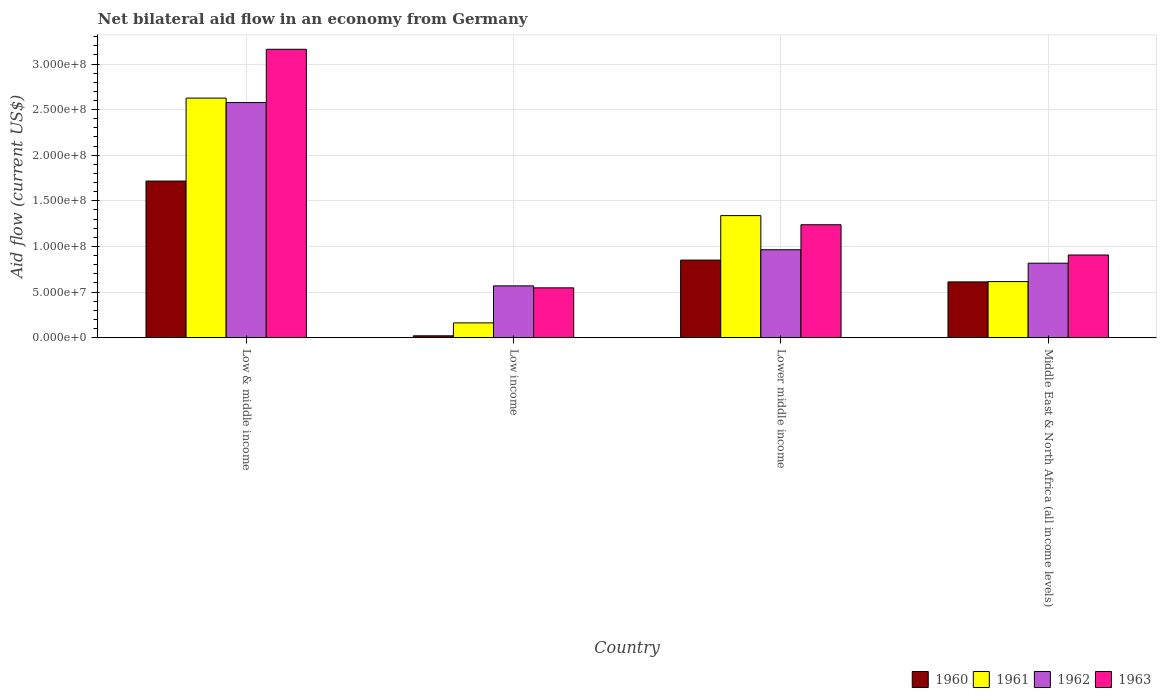How many groups of bars are there?
Provide a succinct answer. 4. Are the number of bars per tick equal to the number of legend labels?
Your answer should be very brief. Yes. How many bars are there on the 3rd tick from the left?
Make the answer very short. 4. How many bars are there on the 1st tick from the right?
Provide a short and direct response. 4. What is the net bilateral aid flow in 1963 in Low & middle income?
Provide a succinct answer. 3.16e+08. Across all countries, what is the maximum net bilateral aid flow in 1961?
Offer a very short reply. 2.63e+08. Across all countries, what is the minimum net bilateral aid flow in 1962?
Your response must be concise. 5.68e+07. In which country was the net bilateral aid flow in 1961 maximum?
Your answer should be very brief. Low & middle income. What is the total net bilateral aid flow in 1962 in the graph?
Your response must be concise. 4.93e+08. What is the difference between the net bilateral aid flow in 1962 in Low & middle income and that in Middle East & North Africa (all income levels)?
Offer a very short reply. 1.76e+08. What is the difference between the net bilateral aid flow in 1962 in Low income and the net bilateral aid flow in 1960 in Lower middle income?
Your answer should be compact. -2.82e+07. What is the average net bilateral aid flow in 1960 per country?
Your response must be concise. 8.00e+07. What is the difference between the net bilateral aid flow of/in 1961 and net bilateral aid flow of/in 1960 in Low income?
Make the answer very short. 1.42e+07. What is the ratio of the net bilateral aid flow in 1961 in Lower middle income to that in Middle East & North Africa (all income levels)?
Your answer should be very brief. 2.18. What is the difference between the highest and the second highest net bilateral aid flow in 1963?
Provide a short and direct response. 2.26e+08. What is the difference between the highest and the lowest net bilateral aid flow in 1961?
Give a very brief answer. 2.46e+08. In how many countries, is the net bilateral aid flow in 1962 greater than the average net bilateral aid flow in 1962 taken over all countries?
Offer a terse response. 1. Is the sum of the net bilateral aid flow in 1963 in Low & middle income and Low income greater than the maximum net bilateral aid flow in 1960 across all countries?
Your response must be concise. Yes. Is it the case that in every country, the sum of the net bilateral aid flow in 1961 and net bilateral aid flow in 1960 is greater than the sum of net bilateral aid flow in 1963 and net bilateral aid flow in 1962?
Offer a terse response. No. What does the 3rd bar from the left in Low & middle income represents?
Offer a terse response. 1962. Are all the bars in the graph horizontal?
Provide a short and direct response. No. What is the difference between two consecutive major ticks on the Y-axis?
Your answer should be compact. 5.00e+07. Are the values on the major ticks of Y-axis written in scientific E-notation?
Offer a very short reply. Yes. Does the graph contain any zero values?
Provide a succinct answer. No. Does the graph contain grids?
Your answer should be compact. Yes. How are the legend labels stacked?
Provide a succinct answer. Horizontal. What is the title of the graph?
Your answer should be compact. Net bilateral aid flow in an economy from Germany. Does "1972" appear as one of the legend labels in the graph?
Make the answer very short. No. What is the Aid flow (current US$) of 1960 in Low & middle income?
Provide a succinct answer. 1.72e+08. What is the Aid flow (current US$) in 1961 in Low & middle income?
Give a very brief answer. 2.63e+08. What is the Aid flow (current US$) in 1962 in Low & middle income?
Offer a very short reply. 2.58e+08. What is the Aid flow (current US$) of 1963 in Low & middle income?
Make the answer very short. 3.16e+08. What is the Aid flow (current US$) of 1960 in Low income?
Your answer should be very brief. 2.02e+06. What is the Aid flow (current US$) of 1961 in Low income?
Offer a terse response. 1.62e+07. What is the Aid flow (current US$) in 1962 in Low income?
Provide a succinct answer. 5.68e+07. What is the Aid flow (current US$) of 1963 in Low income?
Your response must be concise. 5.46e+07. What is the Aid flow (current US$) in 1960 in Lower middle income?
Provide a succinct answer. 8.50e+07. What is the Aid flow (current US$) of 1961 in Lower middle income?
Keep it short and to the point. 1.34e+08. What is the Aid flow (current US$) in 1962 in Lower middle income?
Your response must be concise. 9.64e+07. What is the Aid flow (current US$) of 1963 in Lower middle income?
Make the answer very short. 1.24e+08. What is the Aid flow (current US$) of 1960 in Middle East & North Africa (all income levels)?
Your answer should be very brief. 6.11e+07. What is the Aid flow (current US$) of 1961 in Middle East & North Africa (all income levels)?
Your response must be concise. 6.15e+07. What is the Aid flow (current US$) of 1962 in Middle East & North Africa (all income levels)?
Keep it short and to the point. 8.16e+07. What is the Aid flow (current US$) in 1963 in Middle East & North Africa (all income levels)?
Offer a very short reply. 9.06e+07. Across all countries, what is the maximum Aid flow (current US$) of 1960?
Your answer should be compact. 1.72e+08. Across all countries, what is the maximum Aid flow (current US$) in 1961?
Keep it short and to the point. 2.63e+08. Across all countries, what is the maximum Aid flow (current US$) of 1962?
Give a very brief answer. 2.58e+08. Across all countries, what is the maximum Aid flow (current US$) of 1963?
Keep it short and to the point. 3.16e+08. Across all countries, what is the minimum Aid flow (current US$) of 1960?
Ensure brevity in your answer.  2.02e+06. Across all countries, what is the minimum Aid flow (current US$) of 1961?
Provide a short and direct response. 1.62e+07. Across all countries, what is the minimum Aid flow (current US$) of 1962?
Provide a short and direct response. 5.68e+07. Across all countries, what is the minimum Aid flow (current US$) in 1963?
Keep it short and to the point. 5.46e+07. What is the total Aid flow (current US$) in 1960 in the graph?
Keep it short and to the point. 3.20e+08. What is the total Aid flow (current US$) in 1961 in the graph?
Your answer should be very brief. 4.74e+08. What is the total Aid flow (current US$) in 1962 in the graph?
Your answer should be compact. 4.93e+08. What is the total Aid flow (current US$) in 1963 in the graph?
Your answer should be compact. 5.85e+08. What is the difference between the Aid flow (current US$) in 1960 in Low & middle income and that in Low income?
Make the answer very short. 1.70e+08. What is the difference between the Aid flow (current US$) in 1961 in Low & middle income and that in Low income?
Offer a terse response. 2.46e+08. What is the difference between the Aid flow (current US$) of 1962 in Low & middle income and that in Low income?
Keep it short and to the point. 2.01e+08. What is the difference between the Aid flow (current US$) of 1963 in Low & middle income and that in Low income?
Your answer should be very brief. 2.62e+08. What is the difference between the Aid flow (current US$) of 1960 in Low & middle income and that in Lower middle income?
Offer a very short reply. 8.67e+07. What is the difference between the Aid flow (current US$) in 1961 in Low & middle income and that in Lower middle income?
Keep it short and to the point. 1.29e+08. What is the difference between the Aid flow (current US$) in 1962 in Low & middle income and that in Lower middle income?
Your answer should be very brief. 1.61e+08. What is the difference between the Aid flow (current US$) in 1963 in Low & middle income and that in Lower middle income?
Provide a succinct answer. 1.92e+08. What is the difference between the Aid flow (current US$) of 1960 in Low & middle income and that in Middle East & North Africa (all income levels)?
Keep it short and to the point. 1.11e+08. What is the difference between the Aid flow (current US$) in 1961 in Low & middle income and that in Middle East & North Africa (all income levels)?
Your response must be concise. 2.01e+08. What is the difference between the Aid flow (current US$) in 1962 in Low & middle income and that in Middle East & North Africa (all income levels)?
Give a very brief answer. 1.76e+08. What is the difference between the Aid flow (current US$) in 1963 in Low & middle income and that in Middle East & North Africa (all income levels)?
Offer a terse response. 2.26e+08. What is the difference between the Aid flow (current US$) in 1960 in Low income and that in Lower middle income?
Your answer should be very brief. -8.30e+07. What is the difference between the Aid flow (current US$) of 1961 in Low income and that in Lower middle income?
Provide a succinct answer. -1.18e+08. What is the difference between the Aid flow (current US$) of 1962 in Low income and that in Lower middle income?
Your response must be concise. -3.96e+07. What is the difference between the Aid flow (current US$) in 1963 in Low income and that in Lower middle income?
Provide a short and direct response. -6.92e+07. What is the difference between the Aid flow (current US$) in 1960 in Low income and that in Middle East & North Africa (all income levels)?
Keep it short and to the point. -5.91e+07. What is the difference between the Aid flow (current US$) in 1961 in Low income and that in Middle East & North Africa (all income levels)?
Provide a succinct answer. -4.53e+07. What is the difference between the Aid flow (current US$) in 1962 in Low income and that in Middle East & North Africa (all income levels)?
Provide a short and direct response. -2.49e+07. What is the difference between the Aid flow (current US$) of 1963 in Low income and that in Middle East & North Africa (all income levels)?
Keep it short and to the point. -3.60e+07. What is the difference between the Aid flow (current US$) of 1960 in Lower middle income and that in Middle East & North Africa (all income levels)?
Keep it short and to the point. 2.39e+07. What is the difference between the Aid flow (current US$) in 1961 in Lower middle income and that in Middle East & North Africa (all income levels)?
Keep it short and to the point. 7.24e+07. What is the difference between the Aid flow (current US$) in 1962 in Lower middle income and that in Middle East & North Africa (all income levels)?
Give a very brief answer. 1.47e+07. What is the difference between the Aid flow (current US$) in 1963 in Lower middle income and that in Middle East & North Africa (all income levels)?
Give a very brief answer. 3.32e+07. What is the difference between the Aid flow (current US$) in 1960 in Low & middle income and the Aid flow (current US$) in 1961 in Low income?
Make the answer very short. 1.55e+08. What is the difference between the Aid flow (current US$) in 1960 in Low & middle income and the Aid flow (current US$) in 1962 in Low income?
Your response must be concise. 1.15e+08. What is the difference between the Aid flow (current US$) of 1960 in Low & middle income and the Aid flow (current US$) of 1963 in Low income?
Your answer should be compact. 1.17e+08. What is the difference between the Aid flow (current US$) of 1961 in Low & middle income and the Aid flow (current US$) of 1962 in Low income?
Your answer should be compact. 2.06e+08. What is the difference between the Aid flow (current US$) of 1961 in Low & middle income and the Aid flow (current US$) of 1963 in Low income?
Offer a terse response. 2.08e+08. What is the difference between the Aid flow (current US$) of 1962 in Low & middle income and the Aid flow (current US$) of 1963 in Low income?
Your answer should be very brief. 2.03e+08. What is the difference between the Aid flow (current US$) in 1960 in Low & middle income and the Aid flow (current US$) in 1961 in Lower middle income?
Provide a succinct answer. 3.79e+07. What is the difference between the Aid flow (current US$) of 1960 in Low & middle income and the Aid flow (current US$) of 1962 in Lower middle income?
Offer a very short reply. 7.53e+07. What is the difference between the Aid flow (current US$) of 1960 in Low & middle income and the Aid flow (current US$) of 1963 in Lower middle income?
Your answer should be compact. 4.79e+07. What is the difference between the Aid flow (current US$) of 1961 in Low & middle income and the Aid flow (current US$) of 1962 in Lower middle income?
Your answer should be very brief. 1.66e+08. What is the difference between the Aid flow (current US$) in 1961 in Low & middle income and the Aid flow (current US$) in 1963 in Lower middle income?
Make the answer very short. 1.39e+08. What is the difference between the Aid flow (current US$) of 1962 in Low & middle income and the Aid flow (current US$) of 1963 in Lower middle income?
Your answer should be compact. 1.34e+08. What is the difference between the Aid flow (current US$) of 1960 in Low & middle income and the Aid flow (current US$) of 1961 in Middle East & North Africa (all income levels)?
Offer a very short reply. 1.10e+08. What is the difference between the Aid flow (current US$) in 1960 in Low & middle income and the Aid flow (current US$) in 1962 in Middle East & North Africa (all income levels)?
Offer a very short reply. 9.00e+07. What is the difference between the Aid flow (current US$) of 1960 in Low & middle income and the Aid flow (current US$) of 1963 in Middle East & North Africa (all income levels)?
Your response must be concise. 8.11e+07. What is the difference between the Aid flow (current US$) in 1961 in Low & middle income and the Aid flow (current US$) in 1962 in Middle East & North Africa (all income levels)?
Your answer should be very brief. 1.81e+08. What is the difference between the Aid flow (current US$) of 1961 in Low & middle income and the Aid flow (current US$) of 1963 in Middle East & North Africa (all income levels)?
Your response must be concise. 1.72e+08. What is the difference between the Aid flow (current US$) of 1962 in Low & middle income and the Aid flow (current US$) of 1963 in Middle East & North Africa (all income levels)?
Your answer should be very brief. 1.67e+08. What is the difference between the Aid flow (current US$) in 1960 in Low income and the Aid flow (current US$) in 1961 in Lower middle income?
Offer a terse response. -1.32e+08. What is the difference between the Aid flow (current US$) in 1960 in Low income and the Aid flow (current US$) in 1962 in Lower middle income?
Offer a terse response. -9.43e+07. What is the difference between the Aid flow (current US$) in 1960 in Low income and the Aid flow (current US$) in 1963 in Lower middle income?
Your answer should be compact. -1.22e+08. What is the difference between the Aid flow (current US$) of 1961 in Low income and the Aid flow (current US$) of 1962 in Lower middle income?
Your response must be concise. -8.02e+07. What is the difference between the Aid flow (current US$) in 1961 in Low income and the Aid flow (current US$) in 1963 in Lower middle income?
Ensure brevity in your answer.  -1.08e+08. What is the difference between the Aid flow (current US$) in 1962 in Low income and the Aid flow (current US$) in 1963 in Lower middle income?
Give a very brief answer. -6.70e+07. What is the difference between the Aid flow (current US$) of 1960 in Low income and the Aid flow (current US$) of 1961 in Middle East & North Africa (all income levels)?
Offer a terse response. -5.94e+07. What is the difference between the Aid flow (current US$) of 1960 in Low income and the Aid flow (current US$) of 1962 in Middle East & North Africa (all income levels)?
Your answer should be very brief. -7.96e+07. What is the difference between the Aid flow (current US$) of 1960 in Low income and the Aid flow (current US$) of 1963 in Middle East & North Africa (all income levels)?
Your answer should be compact. -8.86e+07. What is the difference between the Aid flow (current US$) in 1961 in Low income and the Aid flow (current US$) in 1962 in Middle East & North Africa (all income levels)?
Keep it short and to the point. -6.54e+07. What is the difference between the Aid flow (current US$) of 1961 in Low income and the Aid flow (current US$) of 1963 in Middle East & North Africa (all income levels)?
Provide a succinct answer. -7.44e+07. What is the difference between the Aid flow (current US$) of 1962 in Low income and the Aid flow (current US$) of 1963 in Middle East & North Africa (all income levels)?
Your response must be concise. -3.38e+07. What is the difference between the Aid flow (current US$) of 1960 in Lower middle income and the Aid flow (current US$) of 1961 in Middle East & North Africa (all income levels)?
Your answer should be compact. 2.36e+07. What is the difference between the Aid flow (current US$) in 1960 in Lower middle income and the Aid flow (current US$) in 1962 in Middle East & North Africa (all income levels)?
Your response must be concise. 3.38e+06. What is the difference between the Aid flow (current US$) of 1960 in Lower middle income and the Aid flow (current US$) of 1963 in Middle East & North Africa (all income levels)?
Give a very brief answer. -5.59e+06. What is the difference between the Aid flow (current US$) of 1961 in Lower middle income and the Aid flow (current US$) of 1962 in Middle East & North Africa (all income levels)?
Keep it short and to the point. 5.22e+07. What is the difference between the Aid flow (current US$) in 1961 in Lower middle income and the Aid flow (current US$) in 1963 in Middle East & North Africa (all income levels)?
Offer a very short reply. 4.32e+07. What is the difference between the Aid flow (current US$) in 1962 in Lower middle income and the Aid flow (current US$) in 1963 in Middle East & North Africa (all income levels)?
Provide a short and direct response. 5.75e+06. What is the average Aid flow (current US$) in 1960 per country?
Keep it short and to the point. 8.00e+07. What is the average Aid flow (current US$) in 1961 per country?
Make the answer very short. 1.19e+08. What is the average Aid flow (current US$) of 1962 per country?
Your answer should be very brief. 1.23e+08. What is the average Aid flow (current US$) of 1963 per country?
Ensure brevity in your answer.  1.46e+08. What is the difference between the Aid flow (current US$) of 1960 and Aid flow (current US$) of 1961 in Low & middle income?
Give a very brief answer. -9.09e+07. What is the difference between the Aid flow (current US$) in 1960 and Aid flow (current US$) in 1962 in Low & middle income?
Your response must be concise. -8.61e+07. What is the difference between the Aid flow (current US$) in 1960 and Aid flow (current US$) in 1963 in Low & middle income?
Provide a short and direct response. -1.44e+08. What is the difference between the Aid flow (current US$) in 1961 and Aid flow (current US$) in 1962 in Low & middle income?
Your answer should be compact. 4.87e+06. What is the difference between the Aid flow (current US$) of 1961 and Aid flow (current US$) of 1963 in Low & middle income?
Your answer should be compact. -5.35e+07. What is the difference between the Aid flow (current US$) of 1962 and Aid flow (current US$) of 1963 in Low & middle income?
Give a very brief answer. -5.84e+07. What is the difference between the Aid flow (current US$) in 1960 and Aid flow (current US$) in 1961 in Low income?
Provide a succinct answer. -1.42e+07. What is the difference between the Aid flow (current US$) of 1960 and Aid flow (current US$) of 1962 in Low income?
Provide a succinct answer. -5.48e+07. What is the difference between the Aid flow (current US$) in 1960 and Aid flow (current US$) in 1963 in Low income?
Provide a short and direct response. -5.26e+07. What is the difference between the Aid flow (current US$) of 1961 and Aid flow (current US$) of 1962 in Low income?
Your answer should be compact. -4.06e+07. What is the difference between the Aid flow (current US$) of 1961 and Aid flow (current US$) of 1963 in Low income?
Provide a succinct answer. -3.84e+07. What is the difference between the Aid flow (current US$) in 1962 and Aid flow (current US$) in 1963 in Low income?
Provide a succinct answer. 2.16e+06. What is the difference between the Aid flow (current US$) of 1960 and Aid flow (current US$) of 1961 in Lower middle income?
Offer a very short reply. -4.88e+07. What is the difference between the Aid flow (current US$) of 1960 and Aid flow (current US$) of 1962 in Lower middle income?
Your answer should be very brief. -1.13e+07. What is the difference between the Aid flow (current US$) of 1960 and Aid flow (current US$) of 1963 in Lower middle income?
Your response must be concise. -3.88e+07. What is the difference between the Aid flow (current US$) of 1961 and Aid flow (current US$) of 1962 in Lower middle income?
Offer a terse response. 3.75e+07. What is the difference between the Aid flow (current US$) of 1961 and Aid flow (current US$) of 1963 in Lower middle income?
Make the answer very short. 1.00e+07. What is the difference between the Aid flow (current US$) in 1962 and Aid flow (current US$) in 1963 in Lower middle income?
Keep it short and to the point. -2.74e+07. What is the difference between the Aid flow (current US$) of 1960 and Aid flow (current US$) of 1961 in Middle East & North Africa (all income levels)?
Your response must be concise. -3.30e+05. What is the difference between the Aid flow (current US$) in 1960 and Aid flow (current US$) in 1962 in Middle East & North Africa (all income levels)?
Ensure brevity in your answer.  -2.05e+07. What is the difference between the Aid flow (current US$) in 1960 and Aid flow (current US$) in 1963 in Middle East & North Africa (all income levels)?
Your answer should be compact. -2.95e+07. What is the difference between the Aid flow (current US$) in 1961 and Aid flow (current US$) in 1962 in Middle East & North Africa (all income levels)?
Ensure brevity in your answer.  -2.02e+07. What is the difference between the Aid flow (current US$) of 1961 and Aid flow (current US$) of 1963 in Middle East & North Africa (all income levels)?
Offer a very short reply. -2.91e+07. What is the difference between the Aid flow (current US$) in 1962 and Aid flow (current US$) in 1963 in Middle East & North Africa (all income levels)?
Offer a very short reply. -8.97e+06. What is the ratio of the Aid flow (current US$) of 1960 in Low & middle income to that in Low income?
Ensure brevity in your answer.  85. What is the ratio of the Aid flow (current US$) in 1961 in Low & middle income to that in Low income?
Your answer should be very brief. 16.21. What is the ratio of the Aid flow (current US$) in 1962 in Low & middle income to that in Low income?
Ensure brevity in your answer.  4.54. What is the ratio of the Aid flow (current US$) of 1963 in Low & middle income to that in Low income?
Offer a very short reply. 5.79. What is the ratio of the Aid flow (current US$) of 1960 in Low & middle income to that in Lower middle income?
Provide a succinct answer. 2.02. What is the ratio of the Aid flow (current US$) in 1961 in Low & middle income to that in Lower middle income?
Keep it short and to the point. 1.96. What is the ratio of the Aid flow (current US$) in 1962 in Low & middle income to that in Lower middle income?
Your response must be concise. 2.67. What is the ratio of the Aid flow (current US$) in 1963 in Low & middle income to that in Lower middle income?
Your answer should be compact. 2.55. What is the ratio of the Aid flow (current US$) in 1960 in Low & middle income to that in Middle East & North Africa (all income levels)?
Your response must be concise. 2.81. What is the ratio of the Aid flow (current US$) of 1961 in Low & middle income to that in Middle East & North Africa (all income levels)?
Your response must be concise. 4.27. What is the ratio of the Aid flow (current US$) in 1962 in Low & middle income to that in Middle East & North Africa (all income levels)?
Keep it short and to the point. 3.16. What is the ratio of the Aid flow (current US$) of 1963 in Low & middle income to that in Middle East & North Africa (all income levels)?
Keep it short and to the point. 3.49. What is the ratio of the Aid flow (current US$) in 1960 in Low income to that in Lower middle income?
Give a very brief answer. 0.02. What is the ratio of the Aid flow (current US$) of 1961 in Low income to that in Lower middle income?
Keep it short and to the point. 0.12. What is the ratio of the Aid flow (current US$) of 1962 in Low income to that in Lower middle income?
Make the answer very short. 0.59. What is the ratio of the Aid flow (current US$) in 1963 in Low income to that in Lower middle income?
Your response must be concise. 0.44. What is the ratio of the Aid flow (current US$) in 1960 in Low income to that in Middle East & North Africa (all income levels)?
Provide a succinct answer. 0.03. What is the ratio of the Aid flow (current US$) of 1961 in Low income to that in Middle East & North Africa (all income levels)?
Make the answer very short. 0.26. What is the ratio of the Aid flow (current US$) of 1962 in Low income to that in Middle East & North Africa (all income levels)?
Ensure brevity in your answer.  0.7. What is the ratio of the Aid flow (current US$) of 1963 in Low income to that in Middle East & North Africa (all income levels)?
Ensure brevity in your answer.  0.6. What is the ratio of the Aid flow (current US$) of 1960 in Lower middle income to that in Middle East & North Africa (all income levels)?
Your answer should be compact. 1.39. What is the ratio of the Aid flow (current US$) in 1961 in Lower middle income to that in Middle East & North Africa (all income levels)?
Provide a short and direct response. 2.18. What is the ratio of the Aid flow (current US$) in 1962 in Lower middle income to that in Middle East & North Africa (all income levels)?
Provide a succinct answer. 1.18. What is the ratio of the Aid flow (current US$) of 1963 in Lower middle income to that in Middle East & North Africa (all income levels)?
Keep it short and to the point. 1.37. What is the difference between the highest and the second highest Aid flow (current US$) in 1960?
Your response must be concise. 8.67e+07. What is the difference between the highest and the second highest Aid flow (current US$) in 1961?
Your response must be concise. 1.29e+08. What is the difference between the highest and the second highest Aid flow (current US$) in 1962?
Keep it short and to the point. 1.61e+08. What is the difference between the highest and the second highest Aid flow (current US$) in 1963?
Give a very brief answer. 1.92e+08. What is the difference between the highest and the lowest Aid flow (current US$) in 1960?
Provide a short and direct response. 1.70e+08. What is the difference between the highest and the lowest Aid flow (current US$) of 1961?
Offer a very short reply. 2.46e+08. What is the difference between the highest and the lowest Aid flow (current US$) in 1962?
Your answer should be very brief. 2.01e+08. What is the difference between the highest and the lowest Aid flow (current US$) in 1963?
Offer a very short reply. 2.62e+08. 